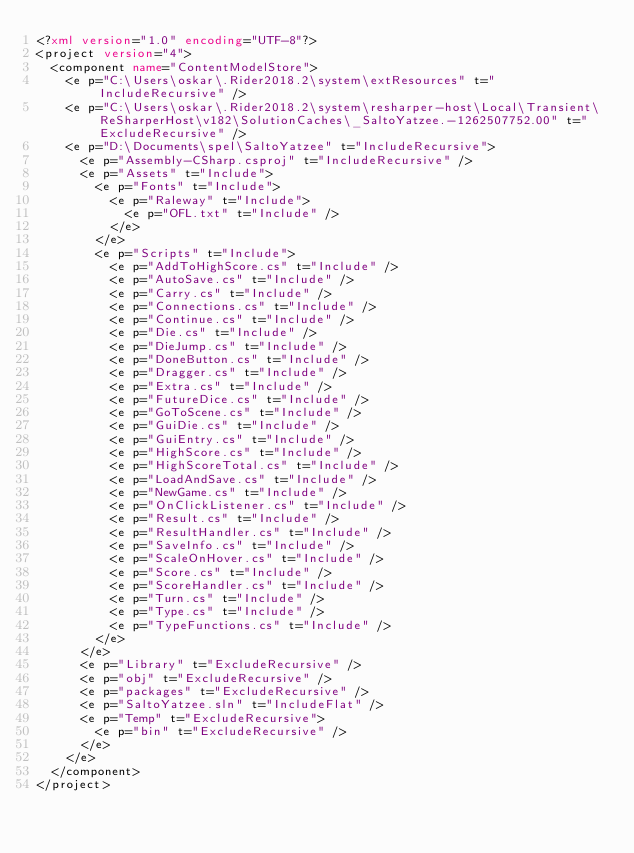<code> <loc_0><loc_0><loc_500><loc_500><_XML_><?xml version="1.0" encoding="UTF-8"?>
<project version="4">
  <component name="ContentModelStore">
    <e p="C:\Users\oskar\.Rider2018.2\system\extResources" t="IncludeRecursive" />
    <e p="C:\Users\oskar\.Rider2018.2\system\resharper-host\Local\Transient\ReSharperHost\v182\SolutionCaches\_SaltoYatzee.-1262507752.00" t="ExcludeRecursive" />
    <e p="D:\Documents\spel\SaltoYatzee" t="IncludeRecursive">
      <e p="Assembly-CSharp.csproj" t="IncludeRecursive" />
      <e p="Assets" t="Include">
        <e p="Fonts" t="Include">
          <e p="Raleway" t="Include">
            <e p="OFL.txt" t="Include" />
          </e>
        </e>
        <e p="Scripts" t="Include">
          <e p="AddToHighScore.cs" t="Include" />
          <e p="AutoSave.cs" t="Include" />
          <e p="Carry.cs" t="Include" />
          <e p="Connections.cs" t="Include" />
          <e p="Continue.cs" t="Include" />
          <e p="Die.cs" t="Include" />
          <e p="DieJump.cs" t="Include" />
          <e p="DoneButton.cs" t="Include" />
          <e p="Dragger.cs" t="Include" />
          <e p="Extra.cs" t="Include" />
          <e p="FutureDice.cs" t="Include" />
          <e p="GoToScene.cs" t="Include" />
          <e p="GuiDie.cs" t="Include" />
          <e p="GuiEntry.cs" t="Include" />
          <e p="HighScore.cs" t="Include" />
          <e p="HighScoreTotal.cs" t="Include" />
          <e p="LoadAndSave.cs" t="Include" />
          <e p="NewGame.cs" t="Include" />
          <e p="OnClickListener.cs" t="Include" />
          <e p="Result.cs" t="Include" />
          <e p="ResultHandler.cs" t="Include" />
          <e p="SaveInfo.cs" t="Include" />
          <e p="ScaleOnHover.cs" t="Include" />
          <e p="Score.cs" t="Include" />
          <e p="ScoreHandler.cs" t="Include" />
          <e p="Turn.cs" t="Include" />
          <e p="Type.cs" t="Include" />
          <e p="TypeFunctions.cs" t="Include" />
        </e>
      </e>
      <e p="Library" t="ExcludeRecursive" />
      <e p="obj" t="ExcludeRecursive" />
      <e p="packages" t="ExcludeRecursive" />
      <e p="SaltoYatzee.sln" t="IncludeFlat" />
      <e p="Temp" t="ExcludeRecursive">
        <e p="bin" t="ExcludeRecursive" />
      </e>
    </e>
  </component>
</project></code> 